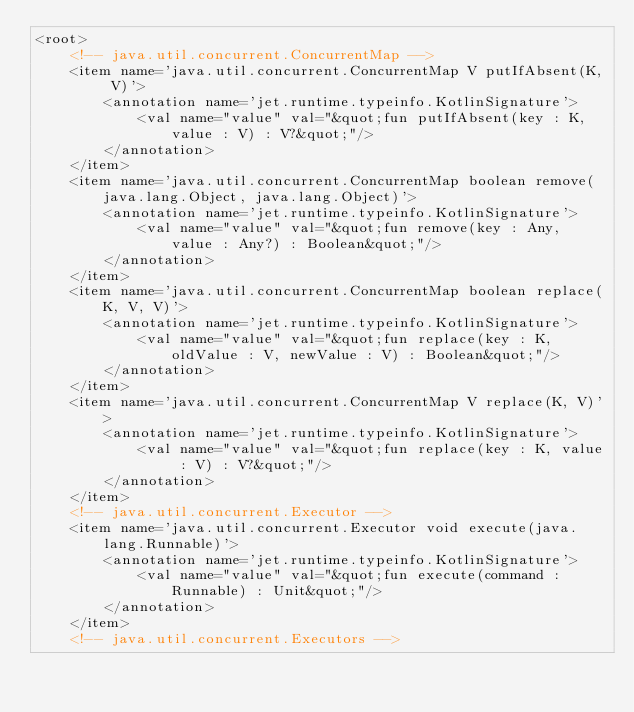Convert code to text. <code><loc_0><loc_0><loc_500><loc_500><_XML_><root>
    <!-- java.util.concurrent.ConcurrentMap -->
    <item name='java.util.concurrent.ConcurrentMap V putIfAbsent(K, V)'>
        <annotation name='jet.runtime.typeinfo.KotlinSignature'>
            <val name="value" val="&quot;fun putIfAbsent(key : K, value : V) : V?&quot;"/>
        </annotation>
    </item>
    <item name='java.util.concurrent.ConcurrentMap boolean remove(java.lang.Object, java.lang.Object)'>
        <annotation name='jet.runtime.typeinfo.KotlinSignature'>
            <val name="value" val="&quot;fun remove(key : Any, value : Any?) : Boolean&quot;"/>
        </annotation>
    </item>
    <item name='java.util.concurrent.ConcurrentMap boolean replace(K, V, V)'>
        <annotation name='jet.runtime.typeinfo.KotlinSignature'>
            <val name="value" val="&quot;fun replace(key : K, oldValue : V, newValue : V) : Boolean&quot;"/>
        </annotation>
    </item>
    <item name='java.util.concurrent.ConcurrentMap V replace(K, V)'>
        <annotation name='jet.runtime.typeinfo.KotlinSignature'>
            <val name="value" val="&quot;fun replace(key : K, value : V) : V?&quot;"/>
        </annotation>
    </item>
    <!-- java.util.concurrent.Executor -->
    <item name='java.util.concurrent.Executor void execute(java.lang.Runnable)'>
        <annotation name='jet.runtime.typeinfo.KotlinSignature'>
            <val name="value" val="&quot;fun execute(command : Runnable) : Unit&quot;"/>
        </annotation>
    </item>
    <!-- java.util.concurrent.Executors --></code> 